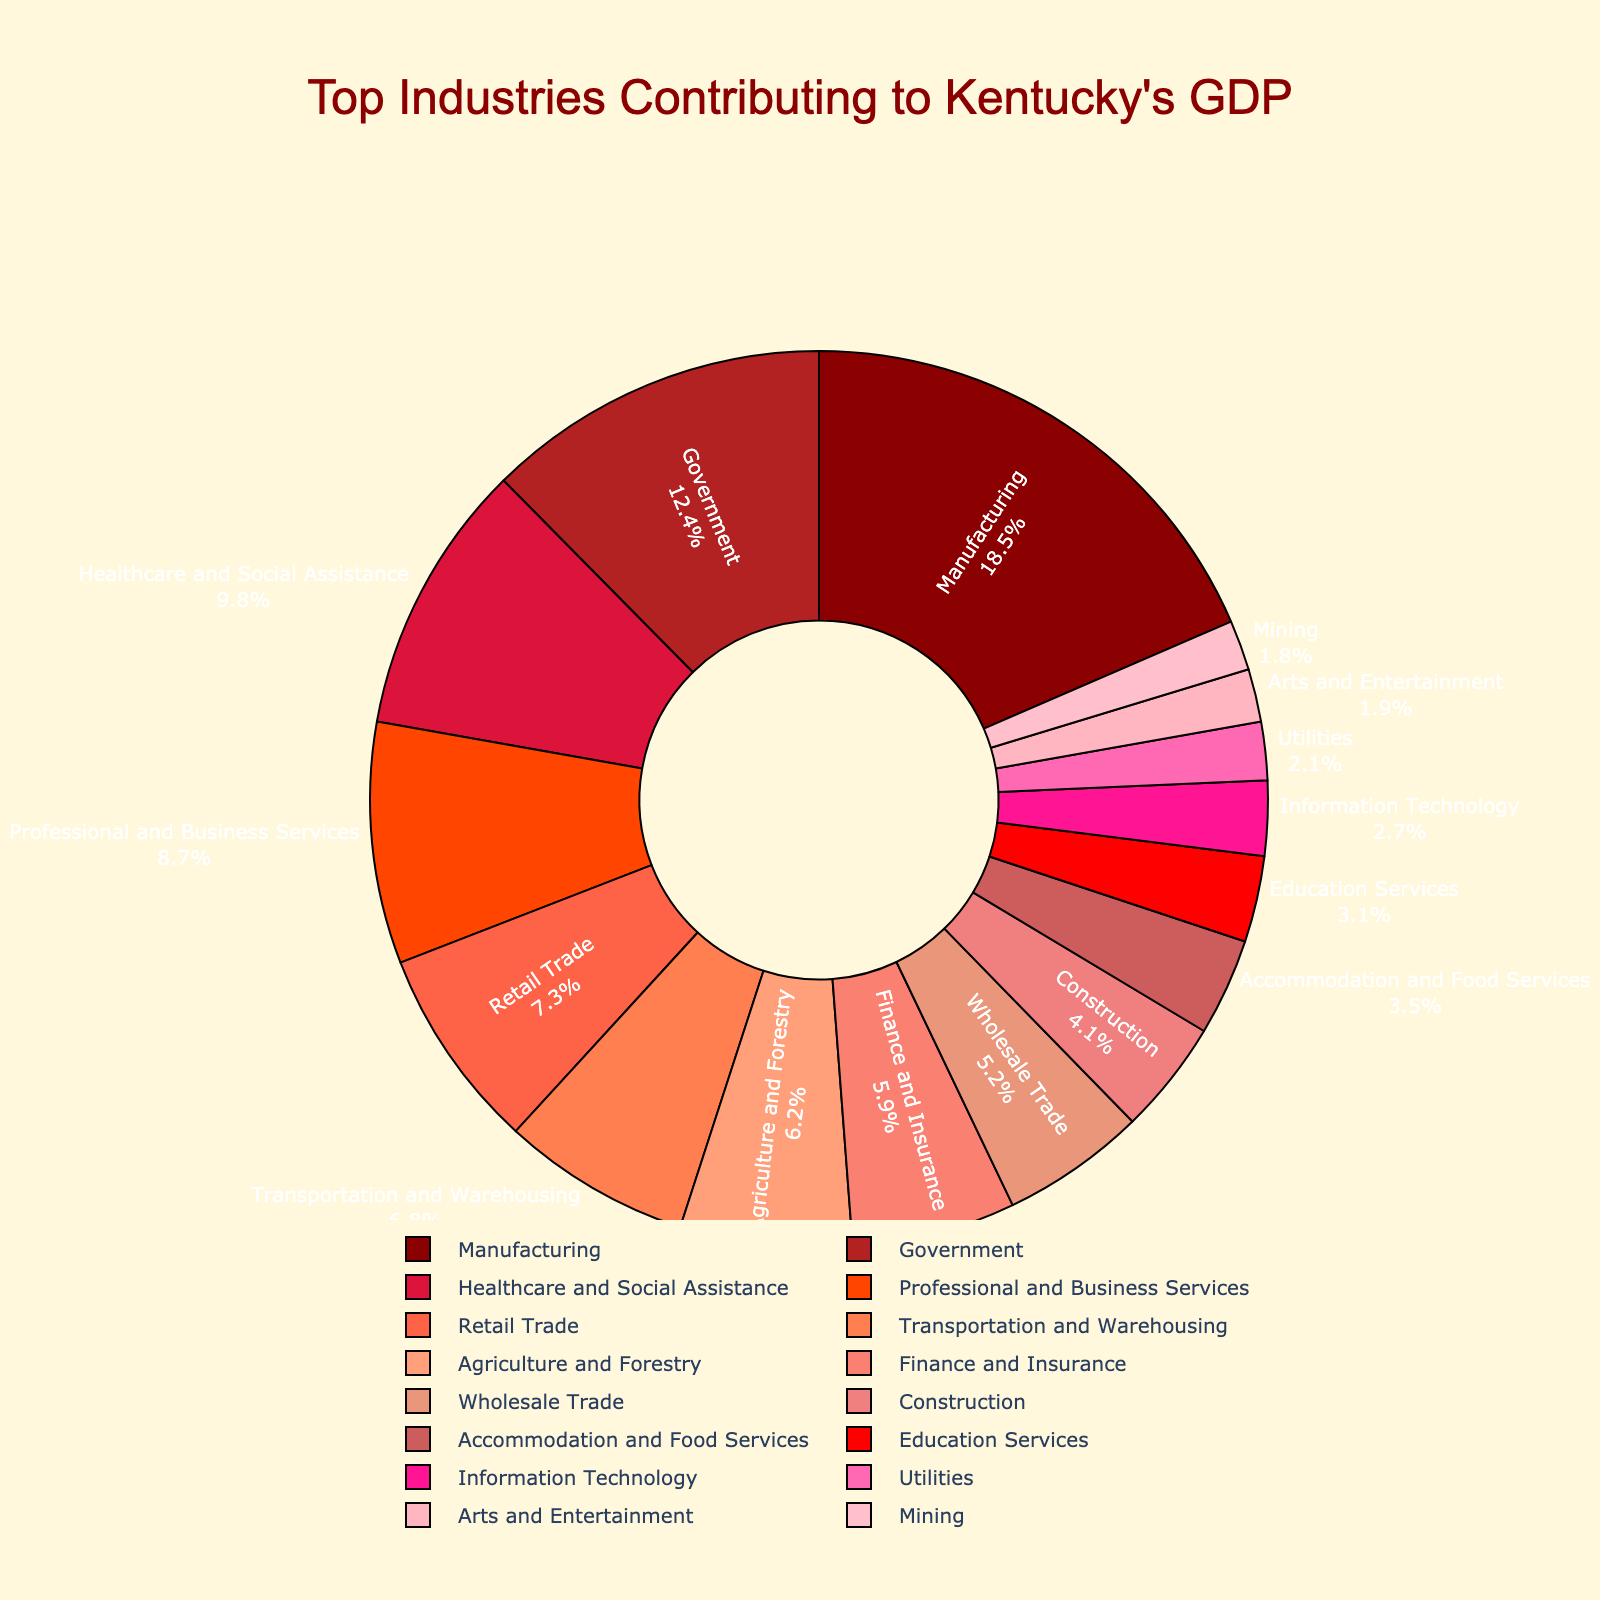Which industry contributes the most to Kentucky's GDP? The sector with the highest percentage in the pie chart contributes the most. Here, Manufacturing has the largest segment with 18.5%.
Answer: Manufacturing What is the combined percentage of Healthcare and Social Assistance and Retail Trade in Kentucky's GDP? Add the percentages of Healthcare and Social Assistance (9.8%) and Retail Trade (7.3%) together. The sum is 9.8 + 7.3 = 17.1%.
Answer: 17.1% Which sectors contribute less than 5% each to Kentucky's GDP, and what are their combined contributions? Identify the sectors with percentages below 5%: Construction (4.1%), Wholesale Trade (5.2%), Education Services (3.1%), Accommodation and Food Services (3.5%), Information Technology (2.7%), Mining (1.8%), Utilities (2.1%), and Arts and Entertainment (1.9%). Summing up their contributions: 4.1 + 5.2 + 3.1 + 3.5 + 2.7 + 1.8 + 2.1 + 1.9 = 24.4%.
Answer: 24.4% How does the contribution of Government compare to Finance and Insurance? Government sector contributes 12.4%, while Finance and Insurance contribute 5.9%. The Government's contribution is higher.
Answer: Government's contribution is higher What is the percentage difference between Manufacturing and Agriculture and Forestry? Subtract the percentage of Agriculture and Forestry (6.2%) from Manufacturing (18.5%): 18.5 - 6.2 = 12.3%.
Answer: 12.3% If you combine Transportation and Warehousing with Professional and Business Services, how close is their combined contribution to that of Manufacturing? Transportation and Warehousing (6.8%) + Professional and Business Services (8.7%) = 15.5%. Compare this with Manufacturing (18.5%). The difference is 18.5 - 15.5 = 3%.
Answer: 3% Which sector is represented by a more reddish color, Manufacturing or Transportation and Warehousing? Manufacturing is represented by a reddish color closer to the more saturated end of the red spectrum, while Transportation and Warehousing is lighter. Thus, Manufacturing is represented by a more reddish color.
Answer: Manufacturing Which industry has a percentage contribution closest to 10%? Healthcare and Social Assistance is closest to 10% with a contribution of 9.8%.
Answer: Healthcare and Social Assistance Are there more sectors contributing more than 10% or less than 5% to Kentucky's GDP? Count the sectors contributing more than 10%: Manufacturing (18.5%) and Government (12.4%). Sectors contributing less than 5%: Construction (4.1%), Education Services (3.1%), Accommodation and Food Services (3.5%), Information Technology (2.7%), Mining (1.8%), Utilities (2.1%), and Arts and Entertainment (1.9%). Two sectors contribute more than 10%, while seven sectors contribute less than 5%.
Answer: More sectors contribute less than 5% 